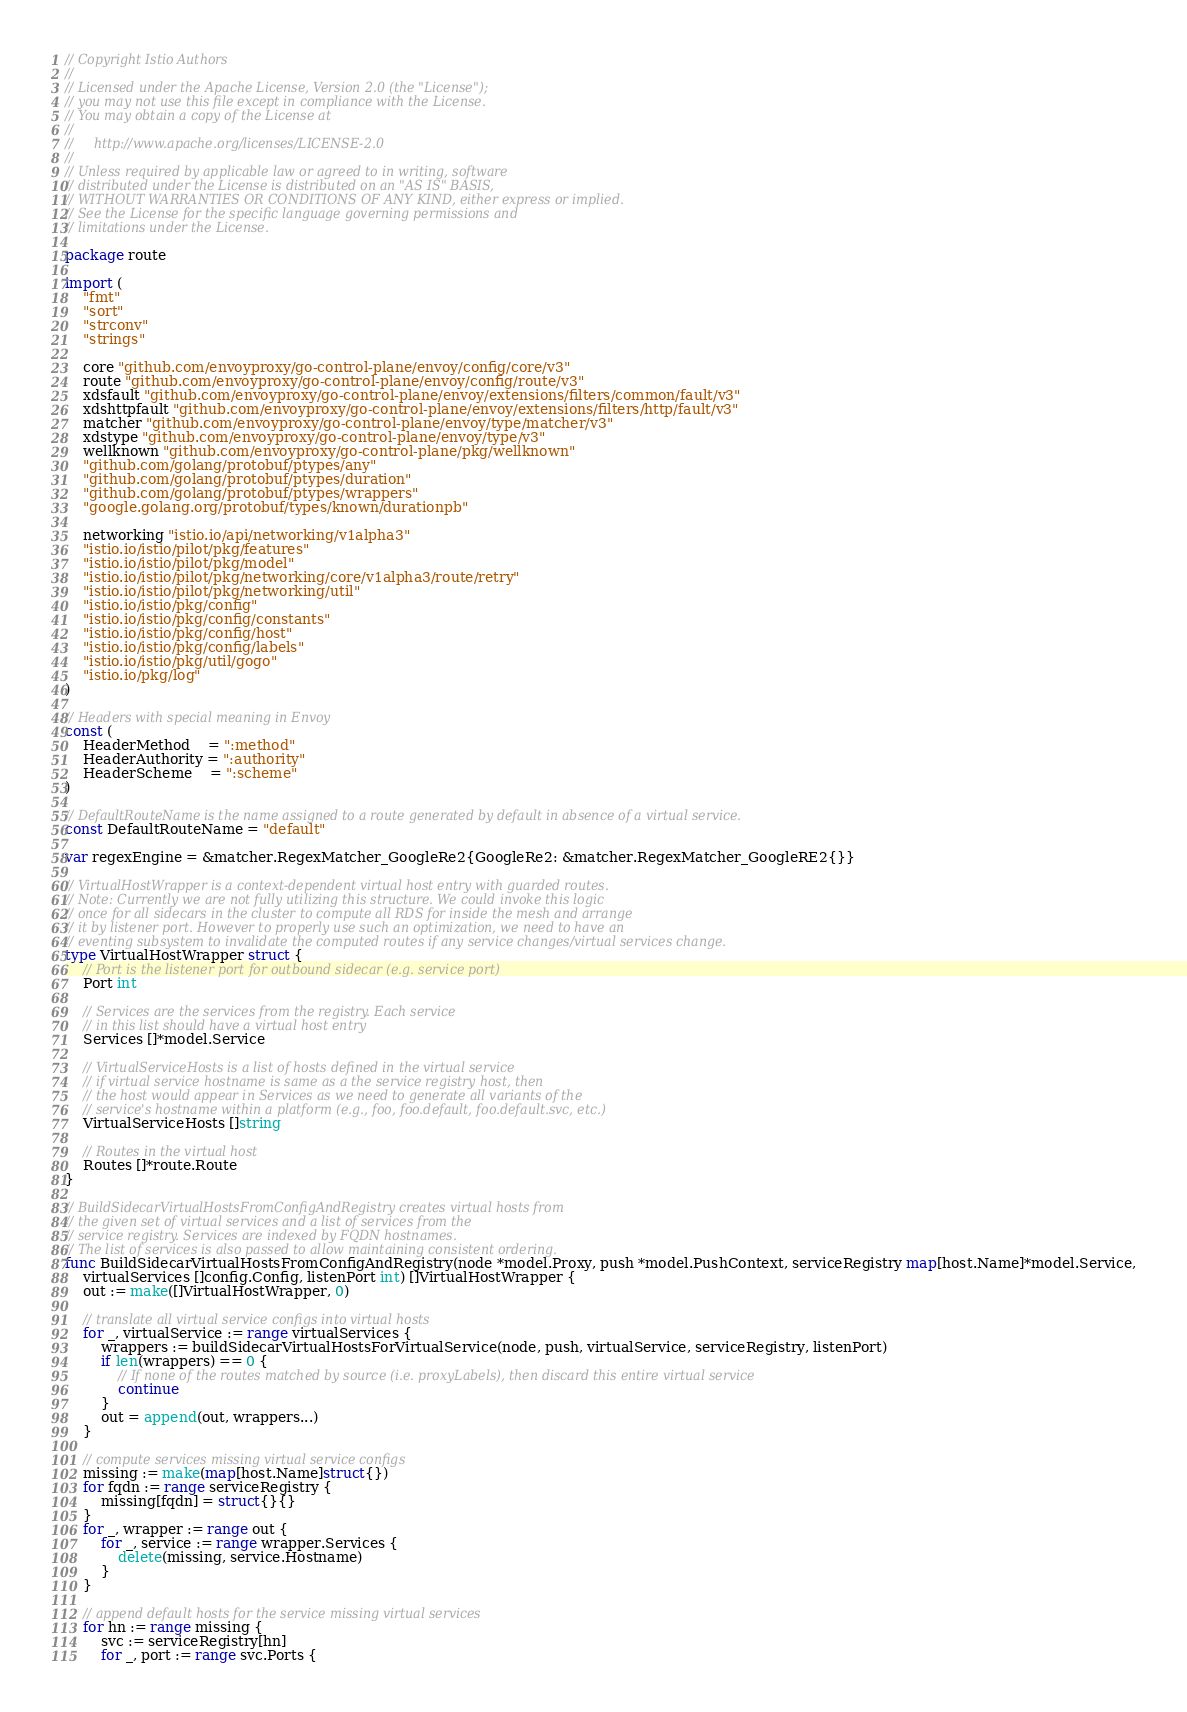<code> <loc_0><loc_0><loc_500><loc_500><_Go_>// Copyright Istio Authors
//
// Licensed under the Apache License, Version 2.0 (the "License");
// you may not use this file except in compliance with the License.
// You may obtain a copy of the License at
//
//     http://www.apache.org/licenses/LICENSE-2.0
//
// Unless required by applicable law or agreed to in writing, software
// distributed under the License is distributed on an "AS IS" BASIS,
// WITHOUT WARRANTIES OR CONDITIONS OF ANY KIND, either express or implied.
// See the License for the specific language governing permissions and
// limitations under the License.

package route

import (
	"fmt"
	"sort"
	"strconv"
	"strings"

	core "github.com/envoyproxy/go-control-plane/envoy/config/core/v3"
	route "github.com/envoyproxy/go-control-plane/envoy/config/route/v3"
	xdsfault "github.com/envoyproxy/go-control-plane/envoy/extensions/filters/common/fault/v3"
	xdshttpfault "github.com/envoyproxy/go-control-plane/envoy/extensions/filters/http/fault/v3"
	matcher "github.com/envoyproxy/go-control-plane/envoy/type/matcher/v3"
	xdstype "github.com/envoyproxy/go-control-plane/envoy/type/v3"
	wellknown "github.com/envoyproxy/go-control-plane/pkg/wellknown"
	"github.com/golang/protobuf/ptypes/any"
	"github.com/golang/protobuf/ptypes/duration"
	"github.com/golang/protobuf/ptypes/wrappers"
	"google.golang.org/protobuf/types/known/durationpb"

	networking "istio.io/api/networking/v1alpha3"
	"istio.io/istio/pilot/pkg/features"
	"istio.io/istio/pilot/pkg/model"
	"istio.io/istio/pilot/pkg/networking/core/v1alpha3/route/retry"
	"istio.io/istio/pilot/pkg/networking/util"
	"istio.io/istio/pkg/config"
	"istio.io/istio/pkg/config/constants"
	"istio.io/istio/pkg/config/host"
	"istio.io/istio/pkg/config/labels"
	"istio.io/istio/pkg/util/gogo"
	"istio.io/pkg/log"
)

// Headers with special meaning in Envoy
const (
	HeaderMethod    = ":method"
	HeaderAuthority = ":authority"
	HeaderScheme    = ":scheme"
)

// DefaultRouteName is the name assigned to a route generated by default in absence of a virtual service.
const DefaultRouteName = "default"

var regexEngine = &matcher.RegexMatcher_GoogleRe2{GoogleRe2: &matcher.RegexMatcher_GoogleRE2{}}

// VirtualHostWrapper is a context-dependent virtual host entry with guarded routes.
// Note: Currently we are not fully utilizing this structure. We could invoke this logic
// once for all sidecars in the cluster to compute all RDS for inside the mesh and arrange
// it by listener port. However to properly use such an optimization, we need to have an
// eventing subsystem to invalidate the computed routes if any service changes/virtual services change.
type VirtualHostWrapper struct {
	// Port is the listener port for outbound sidecar (e.g. service port)
	Port int

	// Services are the services from the registry. Each service
	// in this list should have a virtual host entry
	Services []*model.Service

	// VirtualServiceHosts is a list of hosts defined in the virtual service
	// if virtual service hostname is same as a the service registry host, then
	// the host would appear in Services as we need to generate all variants of the
	// service's hostname within a platform (e.g., foo, foo.default, foo.default.svc, etc.)
	VirtualServiceHosts []string

	// Routes in the virtual host
	Routes []*route.Route
}

// BuildSidecarVirtualHostsFromConfigAndRegistry creates virtual hosts from
// the given set of virtual services and a list of services from the
// service registry. Services are indexed by FQDN hostnames.
// The list of services is also passed to allow maintaining consistent ordering.
func BuildSidecarVirtualHostsFromConfigAndRegistry(node *model.Proxy, push *model.PushContext, serviceRegistry map[host.Name]*model.Service,
	virtualServices []config.Config, listenPort int) []VirtualHostWrapper {
	out := make([]VirtualHostWrapper, 0)

	// translate all virtual service configs into virtual hosts
	for _, virtualService := range virtualServices {
		wrappers := buildSidecarVirtualHostsForVirtualService(node, push, virtualService, serviceRegistry, listenPort)
		if len(wrappers) == 0 {
			// If none of the routes matched by source (i.e. proxyLabels), then discard this entire virtual service
			continue
		}
		out = append(out, wrappers...)
	}

	// compute services missing virtual service configs
	missing := make(map[host.Name]struct{})
	for fqdn := range serviceRegistry {
		missing[fqdn] = struct{}{}
	}
	for _, wrapper := range out {
		for _, service := range wrapper.Services {
			delete(missing, service.Hostname)
		}
	}

	// append default hosts for the service missing virtual services
	for hn := range missing {
		svc := serviceRegistry[hn]
		for _, port := range svc.Ports {</code> 